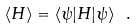Convert formula to latex. <formula><loc_0><loc_0><loc_500><loc_500>\langle H \rangle = \langle \psi | H | \psi \rangle \ .</formula> 